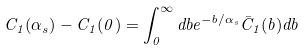Convert formula to latex. <formula><loc_0><loc_0><loc_500><loc_500>C _ { 1 } ( \alpha _ { s } ) - C _ { 1 } ( 0 ) = \int _ { 0 } ^ { \infty } d b e ^ { - b / \alpha _ { s } } \bar { C } _ { 1 } ( b ) d b</formula> 